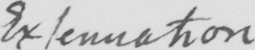What does this handwritten line say? Extenuation 